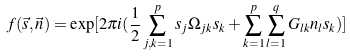<formula> <loc_0><loc_0><loc_500><loc_500>f ( \vec { s } , \vec { n } ) = \exp [ 2 \pi i ( \frac { 1 } { 2 } \sum _ { j , k = 1 } ^ { p } s _ { j } \Omega _ { j k } s _ { k } + \sum _ { k = 1 } ^ { p } \sum _ { l = 1 } ^ { q } G _ { l k } n _ { l } s _ { k } ) ]</formula> 